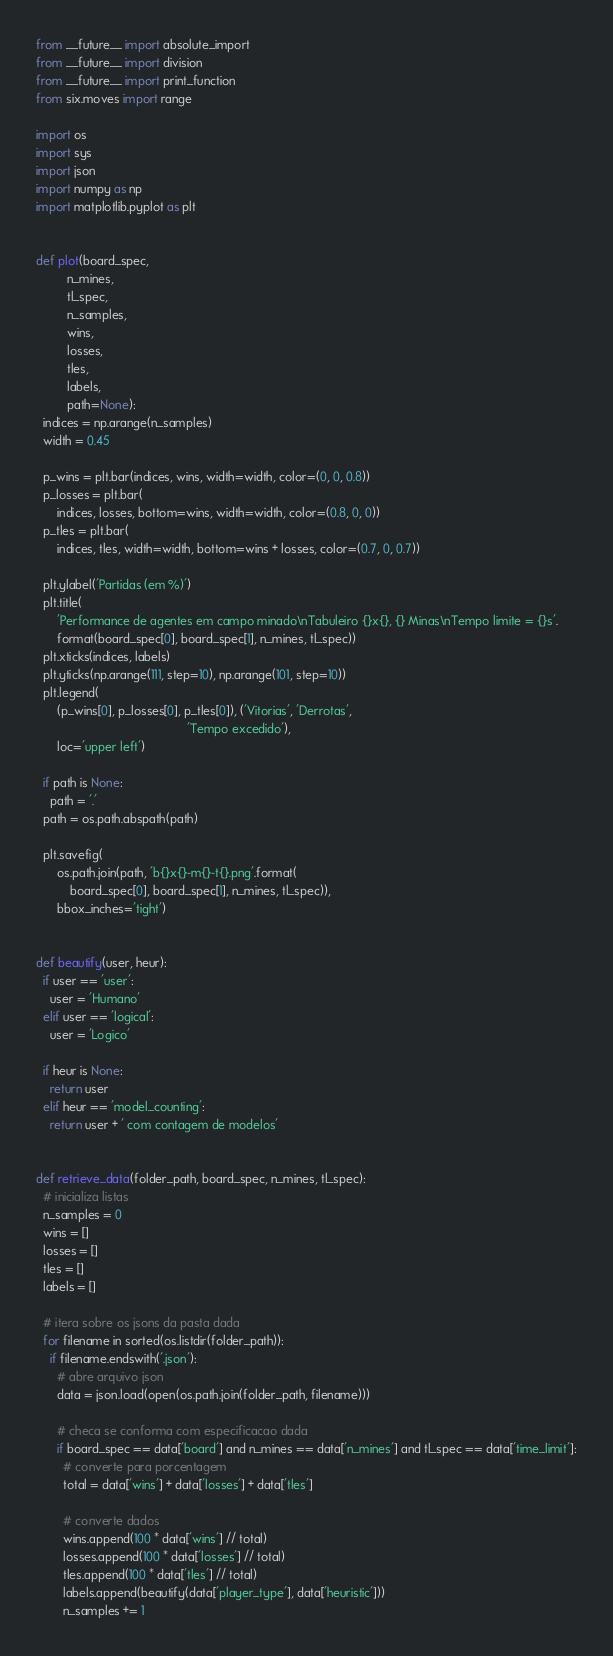Convert code to text. <code><loc_0><loc_0><loc_500><loc_500><_Python_>from __future__ import absolute_import
from __future__ import division
from __future__ import print_function
from six.moves import range

import os
import sys
import json
import numpy as np
import matplotlib.pyplot as plt


def plot(board_spec,
         n_mines,
         tl_spec,
         n_samples,
         wins,
         losses,
         tles,
         labels,
         path=None):
  indices = np.arange(n_samples)
  width = 0.45

  p_wins = plt.bar(indices, wins, width=width, color=(0, 0, 0.8))
  p_losses = plt.bar(
      indices, losses, bottom=wins, width=width, color=(0.8, 0, 0))
  p_tles = plt.bar(
      indices, tles, width=width, bottom=wins + losses, color=(0.7, 0, 0.7))

  plt.ylabel('Partidas (em %)')
  plt.title(
      'Performance de agentes em campo minado\nTabuleiro {}x{}, {} Minas\nTempo limite = {}s'.
      format(board_spec[0], board_spec[1], n_mines, tl_spec))
  plt.xticks(indices, labels)
  plt.yticks(np.arange(111, step=10), np.arange(101, step=10))
  plt.legend(
      (p_wins[0], p_losses[0], p_tles[0]), ('Vitorias', 'Derrotas',
                                            'Tempo excedido'),
      loc='upper left')

  if path is None:
    path = '.'
  path = os.path.abspath(path)

  plt.savefig(
      os.path.join(path, 'b{}x{}-m{}-t{}.png'.format(
          board_spec[0], board_spec[1], n_mines, tl_spec)),
      bbox_inches='tight')


def beautify(user, heur):
  if user == 'user':
    user = 'Humano'
  elif user == 'logical':
    user = 'Logico'

  if heur is None:
    return user
  elif heur == 'model_counting':
    return user + ' com contagem de modelos'


def retrieve_data(folder_path, board_spec, n_mines, tl_spec):
  # inicializa listas
  n_samples = 0
  wins = []
  losses = []
  tles = []
  labels = []

  # itera sobre os jsons da pasta dada
  for filename in sorted(os.listdir(folder_path)):
    if filename.endswith('.json'):
      # abre arquivo json
      data = json.load(open(os.path.join(folder_path, filename)))

      # checa se conforma com especificacao dada
      if board_spec == data['board'] and n_mines == data['n_mines'] and tl_spec == data['time_limit']:
        # converte para porcentagem
        total = data['wins'] + data['losses'] + data['tles']

        # converte dados
        wins.append(100 * data['wins'] // total)
        losses.append(100 * data['losses'] // total)
        tles.append(100 * data['tles'] // total)
        labels.append(beautify(data['player_type'], data['heuristic']))
        n_samples += 1
</code> 